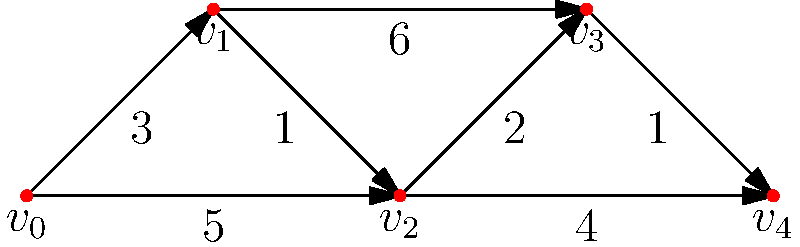In a crisis situation, emergency response teams need to determine the most efficient route from their base (vertex $v_0$) to a critical facility (vertex $v_4$). Given the weighted directed graph representing the road network, where weights indicate travel time in minutes, what is the shortest time (in minutes) required to reach the critical facility? Which algorithm would be most suitable for solving this problem, and why is it relevant to national security? To solve this problem, we can use Dijkstra's algorithm, which is optimal for finding the shortest path in a weighted graph with non-negative edge weights. This algorithm is relevant to national security as it can be used to optimize emergency response times, potentially saving lives and protecting critical infrastructure.

Step-by-step solution using Dijkstra's algorithm:

1) Initialize distances: $d[v_0] = 0$, all others $= \infty$
2) Initialize visited set: $S = \{\}$
3) While $v_4$ is not visited:
   a) Choose vertex $u$ with minimum $d[u]$ not in $S$
   b) Add $u$ to $S$
   c) Update distances to neighbors of $u$

Iteration 1:
- Choose $v_0$, $S = \{v_0\}$
- Update: $d[v_1] = 3$, $d[v_2] = 5$

Iteration 2:
- Choose $v_1$, $S = \{v_0, v_1\}$
- Update: $d[v_2] = \min(5, 3+1) = 4$, $d[v_3] = 3+6 = 9$

Iteration 3:
- Choose $v_2$, $S = \{v_0, v_1, v_2\}$
- Update: $d[v_3] = \min(9, 4+2) = 6$, $d[v_4] = 4+4 = 8$

Iteration 4:
- Choose $v_3$, $S = \{v_0, v_1, v_2, v_3\}$
- Update: $d[v_4] = \min(8, 6+1) = 7$

Iteration 5:
- Choose $v_4$, algorithm terminates

The shortest path is $v_0 \rightarrow v_1 \rightarrow v_2 \rightarrow v_3 \rightarrow v_4$ with a total time of 7 minutes.

Dijkstra's algorithm is suitable because:
1) It guarantees the optimal solution for graphs with non-negative weights.
2) It's efficient, with a time complexity of $O((V+E)\log V)$ using a priority queue.
3) It can be easily adapted for real-time updates, crucial in dynamic emergency situations.

This is relevant to national security as it allows for:
1) Rapid response to threats or emergencies
2) Efficient allocation of resources in crisis situations
3) Improved protection of critical infrastructure and personnel
Answer: 7 minutes; Dijkstra's algorithm 